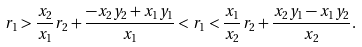Convert formula to latex. <formula><loc_0><loc_0><loc_500><loc_500>r _ { 1 } > \frac { x _ { 2 } } { x _ { 1 } } r _ { 2 } + \frac { - x _ { 2 } y _ { 2 } + x _ { 1 } y _ { 1 } } { x _ { 1 } } < r _ { 1 } < \frac { x _ { 1 } } { x _ { 2 } } r _ { 2 } + \frac { x _ { 2 } y _ { 1 } - x _ { 1 } y _ { 2 } } { x _ { 2 } } .</formula> 